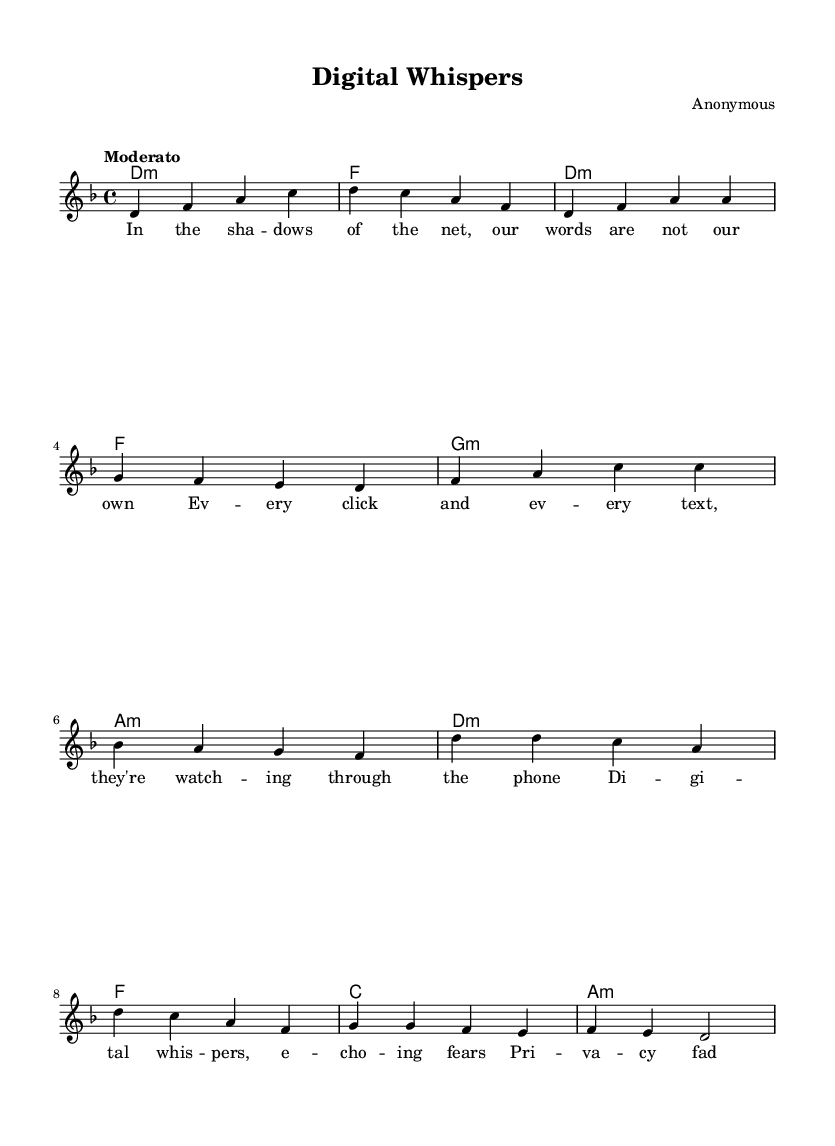What is the key signature of this music? The key signature is indicated at the beginning of the score, and it includes one flat (B♭), which identifies it as D minor.
Answer: D minor What is the time signature of this music? The time signature appears in the beginning of the score as 4/4, meaning there are four beats in each measure and a quarter note gets one beat.
Answer: 4/4 What is the tempo marking for this piece? The tempo is indicated as "Moderato," which suggests a moderate pace for the music.
Answer: Moderato How many measures are in the verse section? By counting the number of distinct bars from the start of the verse to the end, we find there are 8 measures in the verse section in total.
Answer: 8 What is the first lyric of the verse? The first lyric is found in the lyrics section, and it clearly states "In the sha -- dows of the net," as the opening line of the verse.
Answer: In the sha -- dows of the net How many chords are used in the chorus? By analyzing the harmony section during the chorus, we see that there are a total of 4 chords presented, which are repeated in different variations.
Answer: 4 What is the emotional theme of the lyrics? By reading through the lyrics, it becomes evident that the theme revolves around the loss of privacy and the anxiety regarding surveillance, as expressed in phrases like "Big Brother's ears."
Answer: Privacy issues 